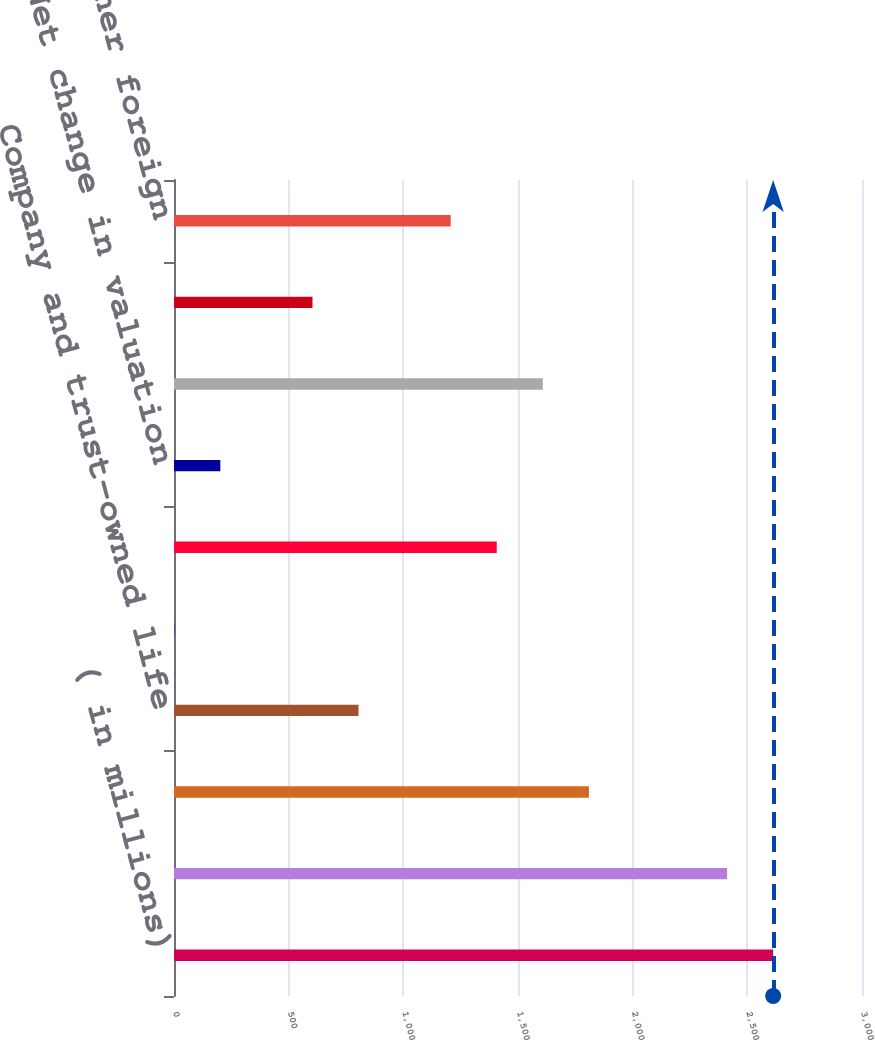<chart> <loc_0><loc_0><loc_500><loc_500><bar_chart><fcel>( in millions)<fcel>Statutory US federal income<fcel>Foreign tax rate differences<fcel>Company and trust-owned life<fcel>Research and development tax<fcel>Manufacturing deduction<fcel>Net change in valuation<fcel>State and local taxes net<fcel>Uncertain tax positions<fcel>Withholding and other foreign<nl><fcel>2612.64<fcel>2411.76<fcel>1809.12<fcel>804.72<fcel>1.2<fcel>1407.36<fcel>202.08<fcel>1608.24<fcel>603.84<fcel>1206.48<nl></chart> 